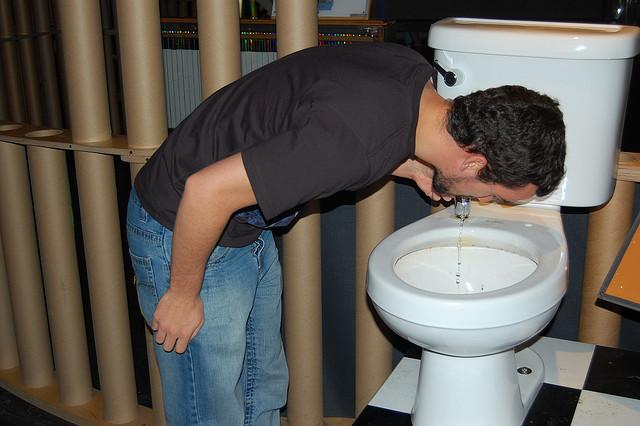Is the man standing straight?
Write a very short answer. No. What type of pants is he wearing?
Be succinct. Jeans. Is this man vomiting?
Be succinct. No. 